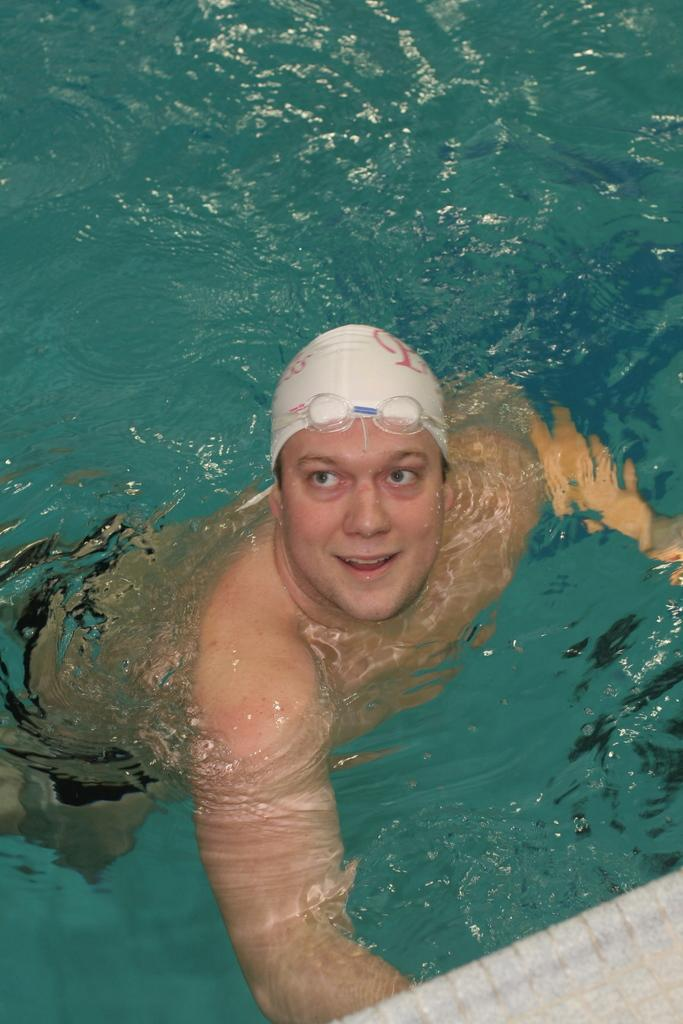Who is present in the image? There is a man in the picture. What is the man wearing on his head? The man is wearing white-colored headwear. What is the man doing in the image? The man is swimming in the water. What type of toad can be seen swimming alongside the man in the image? There is no toad present in the image; the man is swimming alone in the water. 